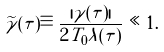<formula> <loc_0><loc_0><loc_500><loc_500>\widetilde { \gamma } ( \tau ) \equiv \frac { | \gamma ( \tau ) | } { 2 T _ { 0 } \lambda ( \tau ) } \ll 1 .</formula> 